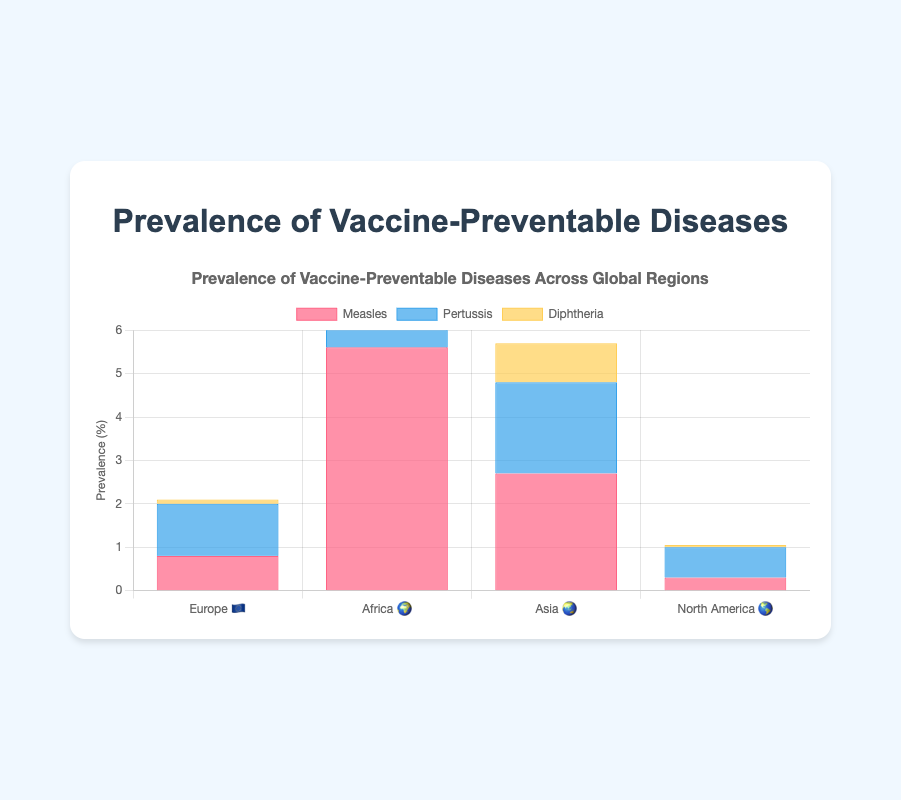What is the title of the figure? The title is usually displayed prominently at the top of the figure and summarizes what the figure represents. Here, it reads "Prevalence of Vaccine-Preventable Diseases Across Global Regions."
Answer: Prevalence of Vaccine-Preventable Diseases Across Global Regions Which region has the highest prevalence of Measles? By examining the bars for Measles across all regions, the tallest one corresponds to Africa with a prevalence of 5.6%.
Answer: Africa 🌍 Which region has the lowest prevalence of Diphtheria? Looking at the bars for Diphtheria, the shortest one is for North America with a prevalence of 0.05%.
Answer: North America 🌎 How does the prevalence of Pertussis in Europe compare to that in Asia? Compare the height of the bars for Pertussis in Europe and Asia. Europe's prevalence is 1.2% while Asia's prevalence is 2.1%.
Answer: Asia 🌏 What is the total prevalence of Diphtheria across all regions? Add the prevalences of Diphtheria in each region: 0.1% (Europe) + 1.5% (Africa) + 0.9% (Asia) + 0.05% (North America) = 2.55%.
Answer: 2.55% Which disease has the highest overall prevalence in all regions combined? Find the largest sum of prevalences for a single disease by adding their values in all regions. Measles: 0.8+5.6+2.7+0.3=9.4, Pertussis: 1.2+3.8+2.1+0.7=7.8, Diphtheria: 0.1+1.5+0.9+0.05=2.55. Therefore, Measles has the highest overall prevalence.
Answer: Measles Which region has the most balanced prevalence rates across all diseases? Compare the differences in heights of the bars for each region. Europe shows the most balanced rates, with prevalences of 0.8%, 1.2%, and 0.1%.
Answer: Europe 🇪🇺 